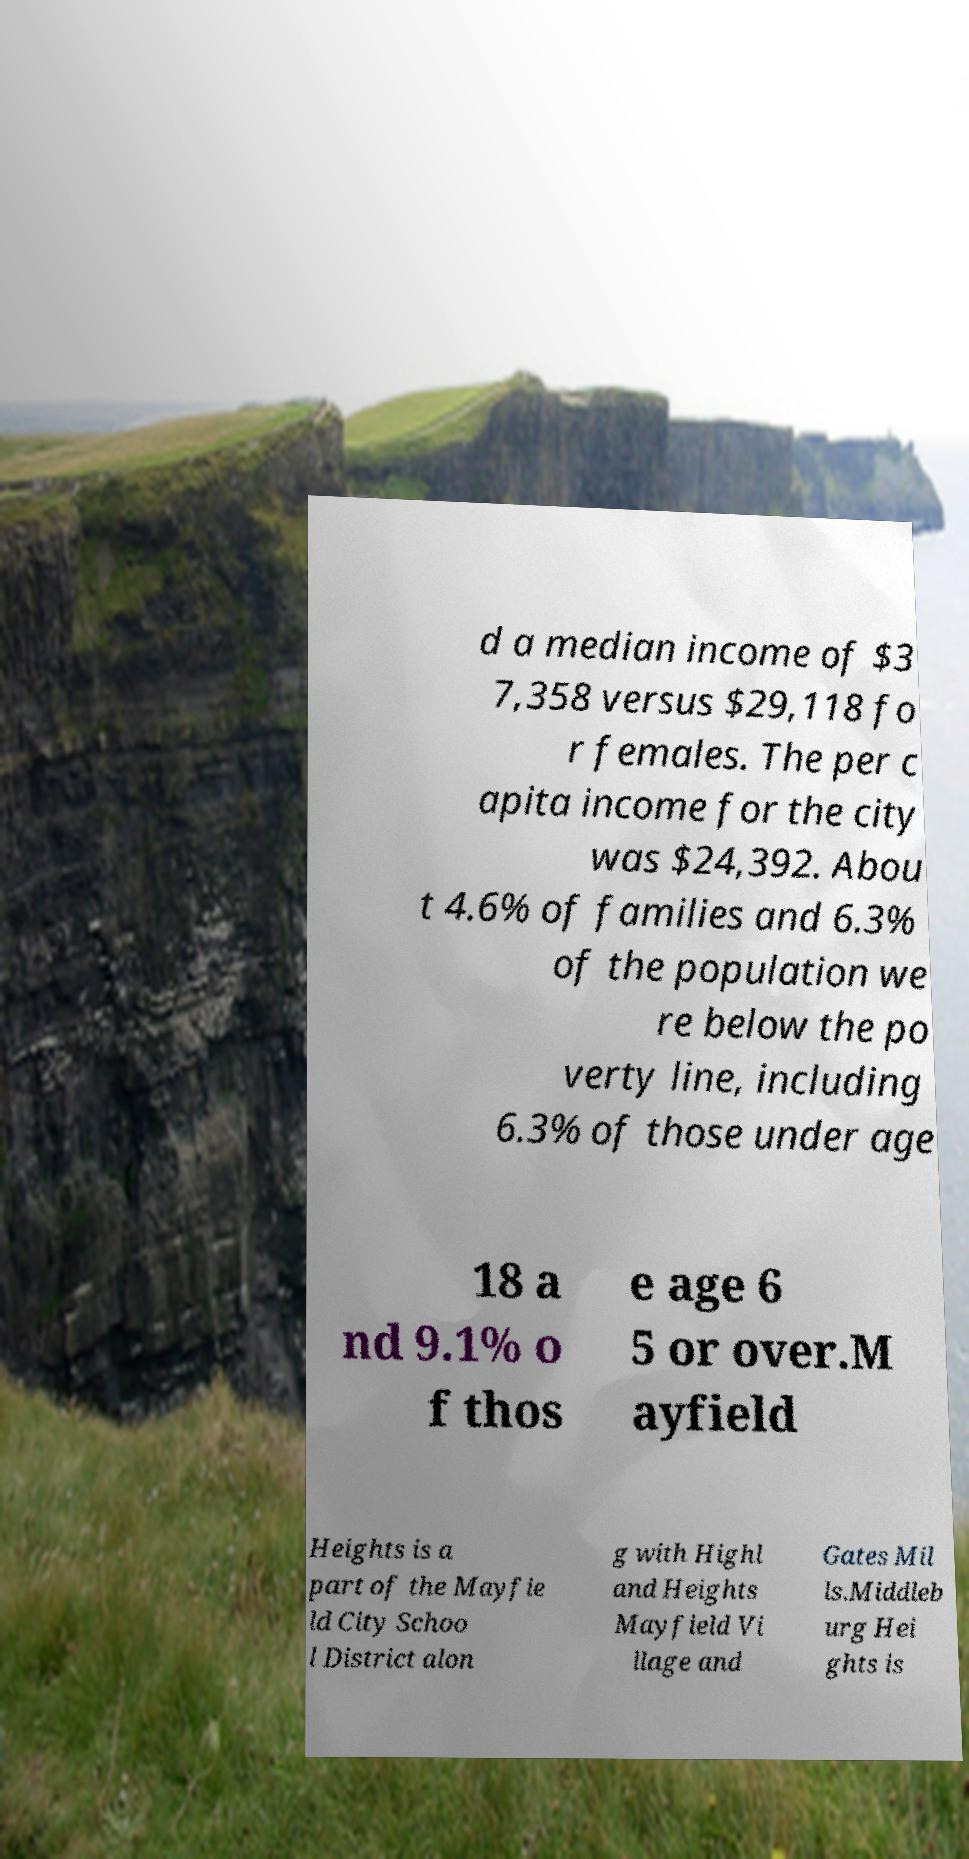There's text embedded in this image that I need extracted. Can you transcribe it verbatim? d a median income of $3 7,358 versus $29,118 fo r females. The per c apita income for the city was $24,392. Abou t 4.6% of families and 6.3% of the population we re below the po verty line, including 6.3% of those under age 18 a nd 9.1% o f thos e age 6 5 or over.M ayfield Heights is a part of the Mayfie ld City Schoo l District alon g with Highl and Heights Mayfield Vi llage and Gates Mil ls.Middleb urg Hei ghts is 